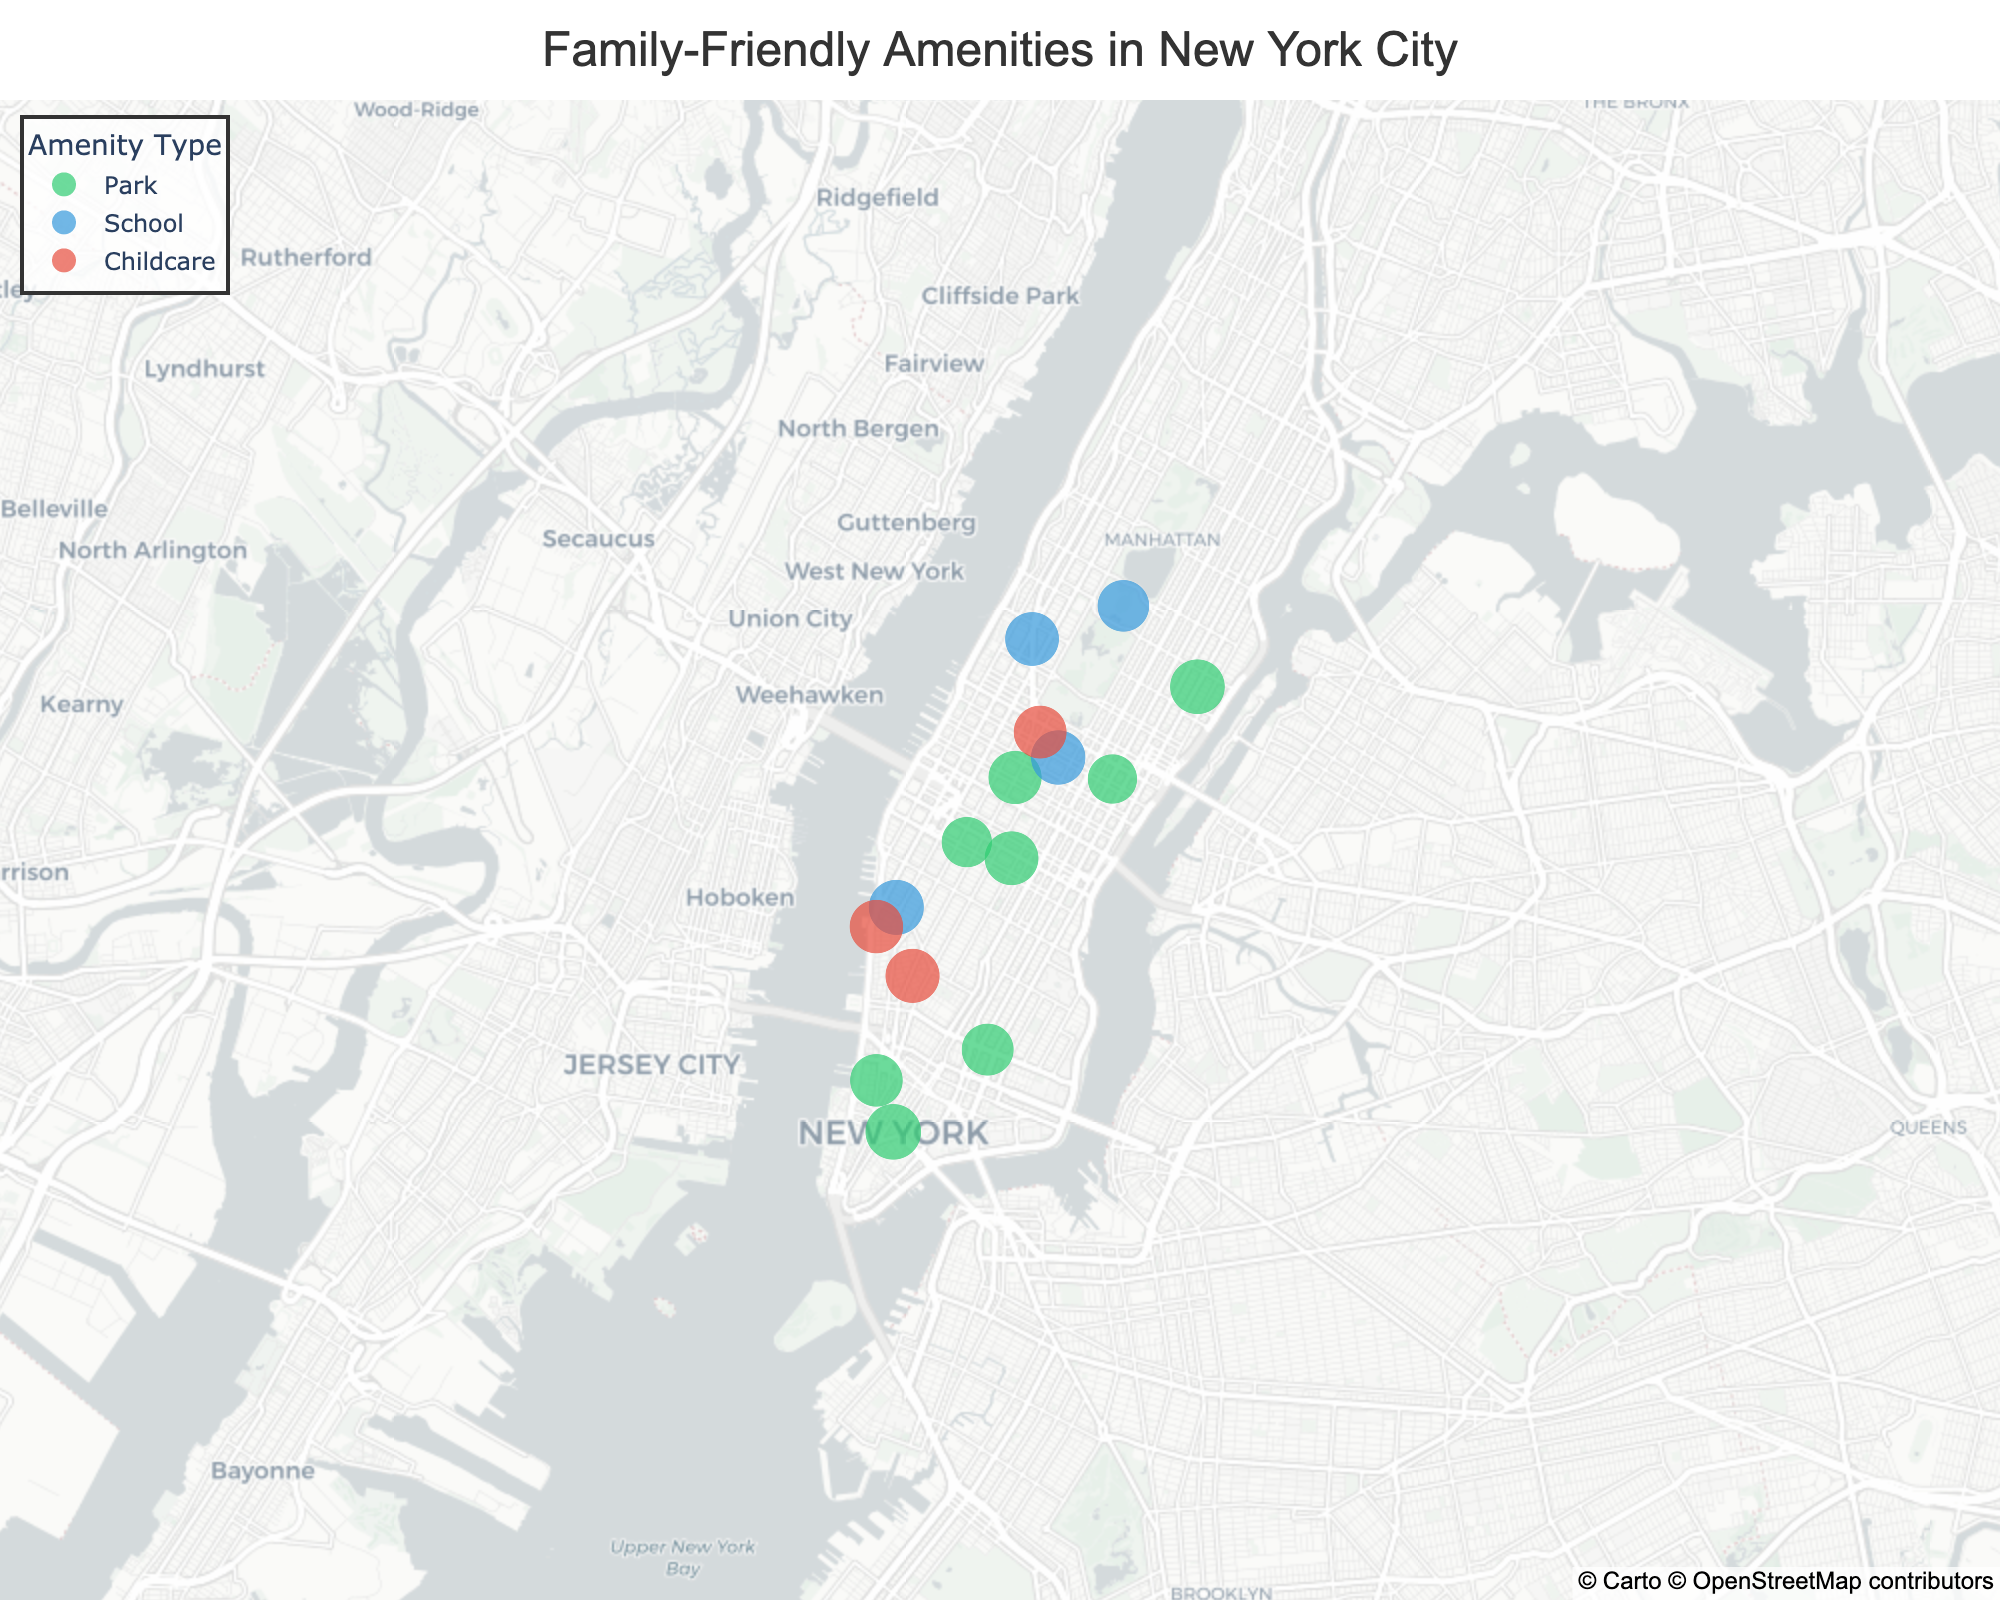What types of amenities are represented in the figure? The figure legend indicates three types of amenities with distinct colors: parks (green), schools (blue), and childcare centers (red).
Answer: Parks, Schools, Childcare centers Which amenity has the highest family-friendly rating? By inspecting the hover data for each amenity, it can be determined that "Central Park," a park, has the highest family-friendly rating of 9.5.
Answer: Central Park How are the sizes of the markers determined in the plot? The sizes of the markers in the plot correspond to the family-friendly ratings of the amenities. Larger markers indicate higher family-friendly ratings.
Answer: Family-friendly rating What is the average family-friendly rating of the parks in the figure? The family-friendly ratings for parks are: 9.5, 8.7, 8.9, 8.5, 7.8, 7.5, 8.3, 9.2. The sum is 68.4, and there are 8 parks. The average rating is 68.4 / 8 = 8.55.
Answer: 8.55 Which area of the city has the highest concentration of family-friendly amenities? By visual inspection of the scatter plot, the Midtown East area seems to have a higher concentration of various amenities, including parks, schools, and childcare centers.
Answer: Midtown East Are there more schools or more parks represented in the figure? From the hover data and legend, we can count the number of schools (5) and parks (8). Thus, there are more parks than schools.
Answer: Parks Which childcare center has the highest family-friendly rating? By examining the hover data, "Bright Horizons at Greenwich Village" has the highest family-friendly rating of 9.0 among childcare centers.
Answer: Bright Horizons at Greenwich Village What is the average family-friendly rating across all amenities? Sum all ratings (9.5, 8.7, 8.2, 9.0, 8.9, 8.5, 9.1, 7.8, 8.8, 8.9, 8.6, 7.5, 8.3, 9.3, 9.2), which equals 130.3. There are 15 amenities. The average rating is 130.3 / 15 = 8.6866, approximately 8.69.
Answer: 8.69 Which school has the lowest family-friendly rating and what is its value? By checking the hover data for schools, "PS 158 Bayard Taylor" has the lowest family-friendly rating of 8.2.
Answer: PS 158 Bayard Taylor, 8.2 How many amenities have a family-friendly rating greater than 9.0? The amenities with ratings greater than 9.0 are "Central Park" (9.5), "Little Red School House" (9.3), and "Asphalt Green" (9.2), totaling 3 amenities.
Answer: 3 